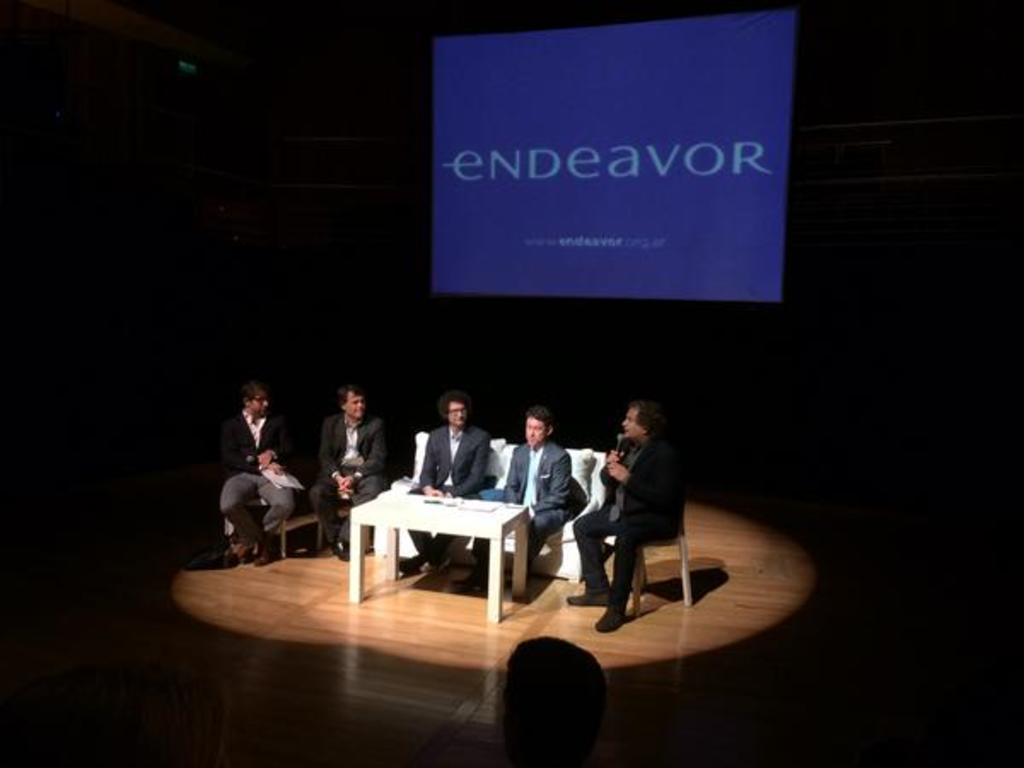How many people are in the image? There are five persons in the image. What are the people wearing? All five persons are wearing suits. How are the people arranged in the image? Two of the persons are sitting on a white sofa, and the remaining three persons are sitting in chairs. What is the color of the background in the image? The background color is blue. What word is written on the background? The word "endeavor" is written on the background. What is the angle of the boundary between the blue background and the white sofa? There is no boundary between the blue background and the white sofa mentioned in the image, and therefore no angle can be determined. 